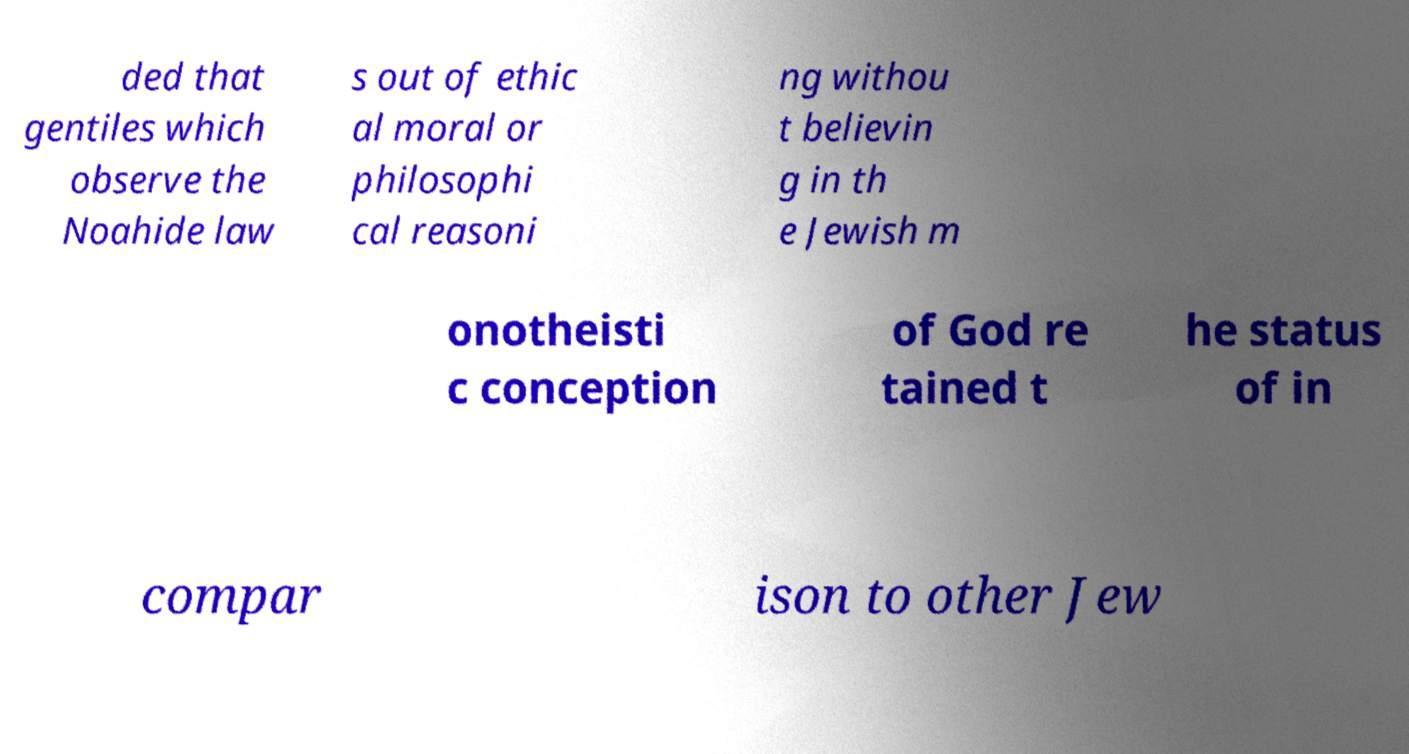What messages or text are displayed in this image? I need them in a readable, typed format. ded that gentiles which observe the Noahide law s out of ethic al moral or philosophi cal reasoni ng withou t believin g in th e Jewish m onotheisti c conception of God re tained t he status of in compar ison to other Jew 